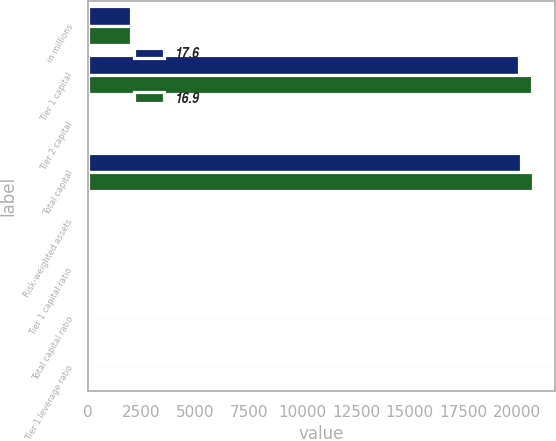Convert chart to OTSL. <chart><loc_0><loc_0><loc_500><loc_500><stacked_bar_chart><ecel><fcel>in millions<fcel>Tier 1 capital<fcel>Tier 2 capital<fcel>Total capital<fcel>Risk-weighted assets<fcel>Tier 1 capital ratio<fcel>Total capital ratio<fcel>Tier 1 leverage ratio<nl><fcel>17.6<fcel>2013<fcel>20086<fcel>116<fcel>20202<fcel>77.5<fcel>14.9<fcel>15<fcel>16.9<nl><fcel>16.9<fcel>2012<fcel>20704<fcel>39<fcel>20743<fcel>77.5<fcel>18.9<fcel>18.9<fcel>17.6<nl></chart> 